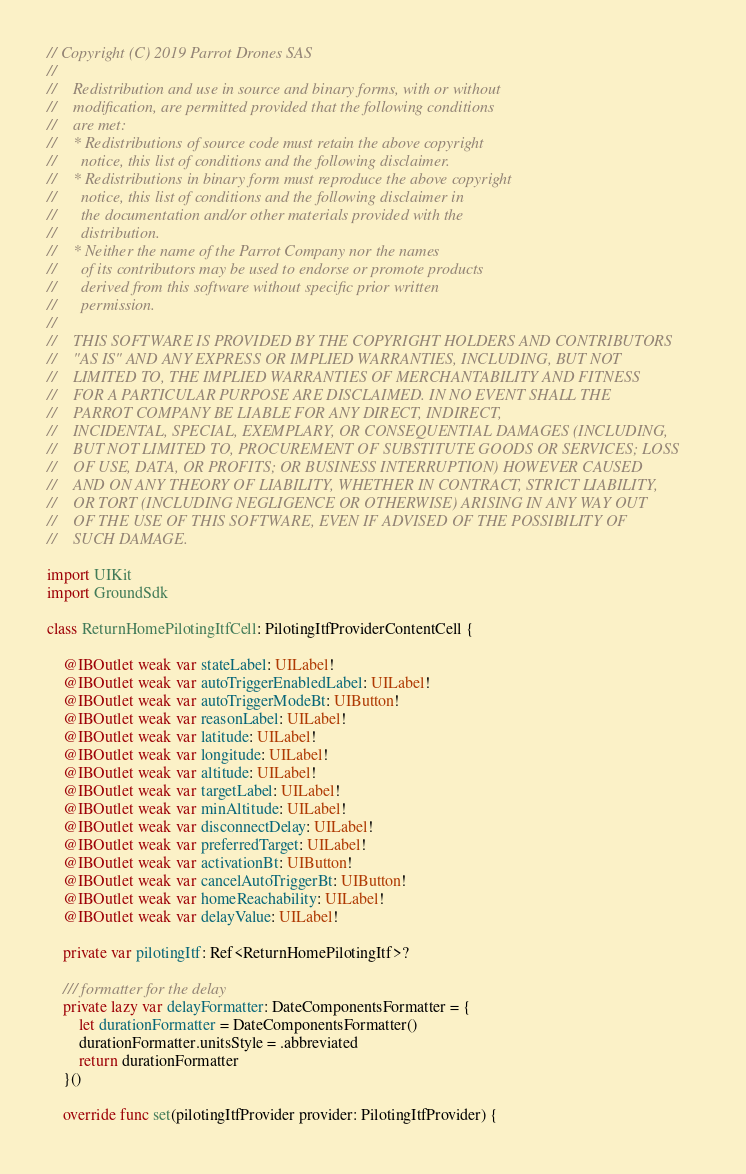Convert code to text. <code><loc_0><loc_0><loc_500><loc_500><_Swift_>// Copyright (C) 2019 Parrot Drones SAS
//
//    Redistribution and use in source and binary forms, with or without
//    modification, are permitted provided that the following conditions
//    are met:
//    * Redistributions of source code must retain the above copyright
//      notice, this list of conditions and the following disclaimer.
//    * Redistributions in binary form must reproduce the above copyright
//      notice, this list of conditions and the following disclaimer in
//      the documentation and/or other materials provided with the
//      distribution.
//    * Neither the name of the Parrot Company nor the names
//      of its contributors may be used to endorse or promote products
//      derived from this software without specific prior written
//      permission.
//
//    THIS SOFTWARE IS PROVIDED BY THE COPYRIGHT HOLDERS AND CONTRIBUTORS
//    "AS IS" AND ANY EXPRESS OR IMPLIED WARRANTIES, INCLUDING, BUT NOT
//    LIMITED TO, THE IMPLIED WARRANTIES OF MERCHANTABILITY AND FITNESS
//    FOR A PARTICULAR PURPOSE ARE DISCLAIMED. IN NO EVENT SHALL THE
//    PARROT COMPANY BE LIABLE FOR ANY DIRECT, INDIRECT,
//    INCIDENTAL, SPECIAL, EXEMPLARY, OR CONSEQUENTIAL DAMAGES (INCLUDING,
//    BUT NOT LIMITED TO, PROCUREMENT OF SUBSTITUTE GOODS OR SERVICES; LOSS
//    OF USE, DATA, OR PROFITS; OR BUSINESS INTERRUPTION) HOWEVER CAUSED
//    AND ON ANY THEORY OF LIABILITY, WHETHER IN CONTRACT, STRICT LIABILITY,
//    OR TORT (INCLUDING NEGLIGENCE OR OTHERWISE) ARISING IN ANY WAY OUT
//    OF THE USE OF THIS SOFTWARE, EVEN IF ADVISED OF THE POSSIBILITY OF
//    SUCH DAMAGE.

import UIKit
import GroundSdk

class ReturnHomePilotingItfCell: PilotingItfProviderContentCell {

    @IBOutlet weak var stateLabel: UILabel!
    @IBOutlet weak var autoTriggerEnabledLabel: UILabel!
    @IBOutlet weak var autoTriggerModeBt: UIButton!
    @IBOutlet weak var reasonLabel: UILabel!
    @IBOutlet weak var latitude: UILabel!
    @IBOutlet weak var longitude: UILabel!
    @IBOutlet weak var altitude: UILabel!
    @IBOutlet weak var targetLabel: UILabel!
    @IBOutlet weak var minAltitude: UILabel!
    @IBOutlet weak var disconnectDelay: UILabel!
    @IBOutlet weak var preferredTarget: UILabel!
    @IBOutlet weak var activationBt: UIButton!
    @IBOutlet weak var cancelAutoTriggerBt: UIButton!
    @IBOutlet weak var homeReachability: UILabel!
    @IBOutlet weak var delayValue: UILabel!

    private var pilotingItf: Ref<ReturnHomePilotingItf>?

    /// formatter for the delay
    private lazy var delayFormatter: DateComponentsFormatter = {
        let durationFormatter = DateComponentsFormatter()
        durationFormatter.unitsStyle = .abbreviated
        return durationFormatter
    }()

    override func set(pilotingItfProvider provider: PilotingItfProvider) {</code> 